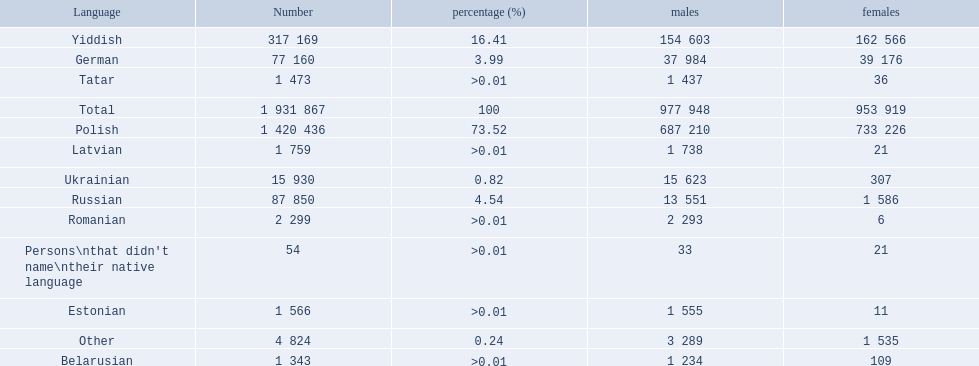What were all the languages? Polish, Yiddish, Russian, German, Ukrainian, Romanian, Latvian, Estonian, Tatar, Belarusian, Other, Persons\nthat didn't name\ntheir native language. For these, how many people spoke them? 1 420 436, 317 169, 87 850, 77 160, 15 930, 2 299, 1 759, 1 566, 1 473, 1 343, 4 824, 54. Of these, which is the largest number of speakers? 1 420 436. Which language corresponds to this number? Polish. 